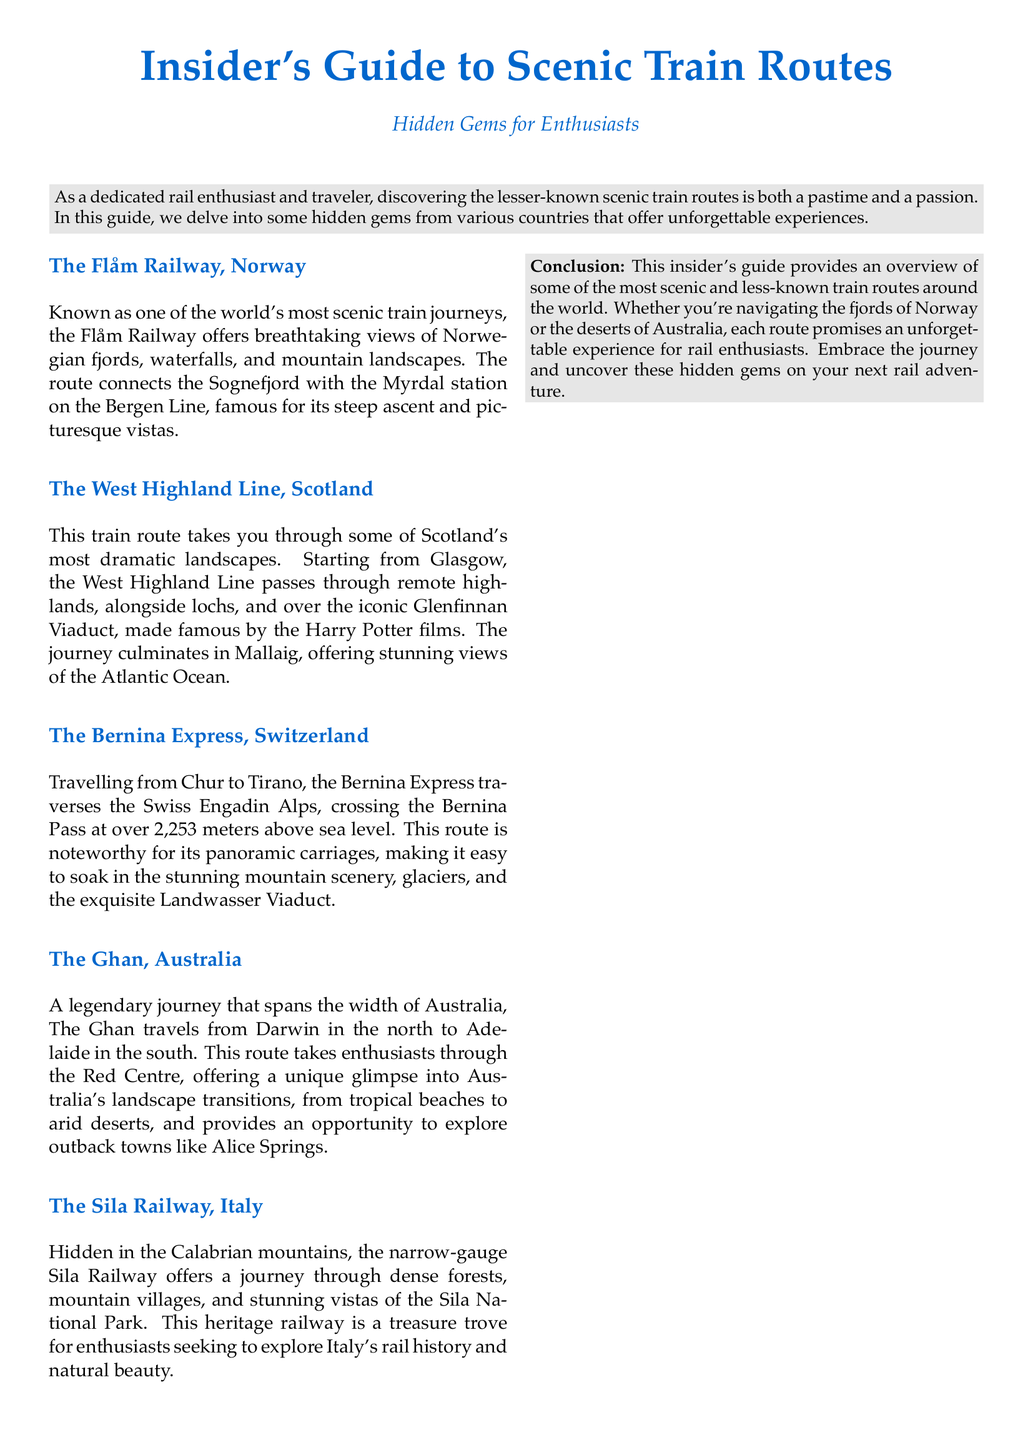What is the name of the railway in Norway? The document mentions the Flåm Railway as the scenic train route in Norway.
Answer: Flåm Railway Which iconic structure does the West Highland Line pass over? The document states that the West Highland Line passes over the Glenfinnan Viaduct.
Answer: Glenfinnan Viaduct What is the altitude of the Bernina Pass? The document provides the altitude of the Bernina Pass, which is stated to be over 2,253 meters above sea level.
Answer: 2,253 meters How many train routes are described in this guide? The document lists five scenic train routes.
Answer: Five Which Australian city is the starting point of The Ghan? According to the document, The Ghan starts in Darwin.
Answer: Darwin What type of railway is the Sila Railway categorized as? The document refers to the Sila Railway as a narrow-gauge heritage railway.
Answer: Narrow-gauge heritage railway Which continent features the Ghan train route? The document indicates that The Ghan travels through Australia, placing it on the continent of Australia.
Answer: Australia What is the primary theme of the document? The document's focus is on providing an insider's guide to scenic and hidden gem train routes.
Answer: Scenic train routes 